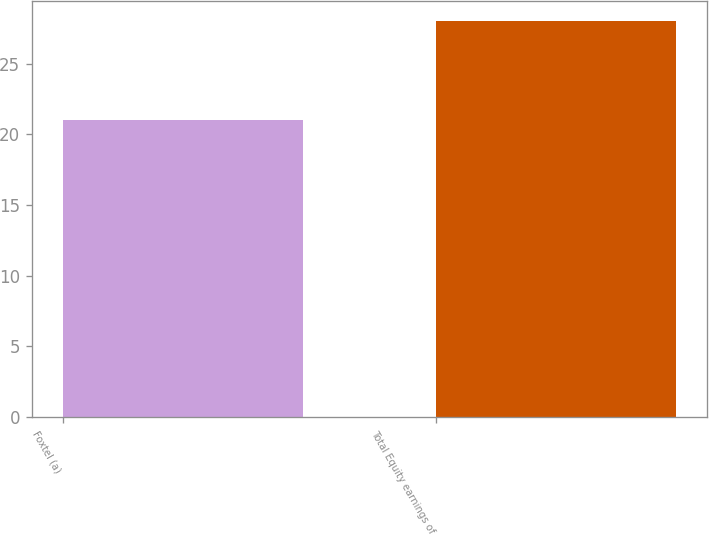Convert chart. <chart><loc_0><loc_0><loc_500><loc_500><bar_chart><fcel>Foxtel (a)<fcel>Total Equity earnings of<nl><fcel>21<fcel>28<nl></chart> 